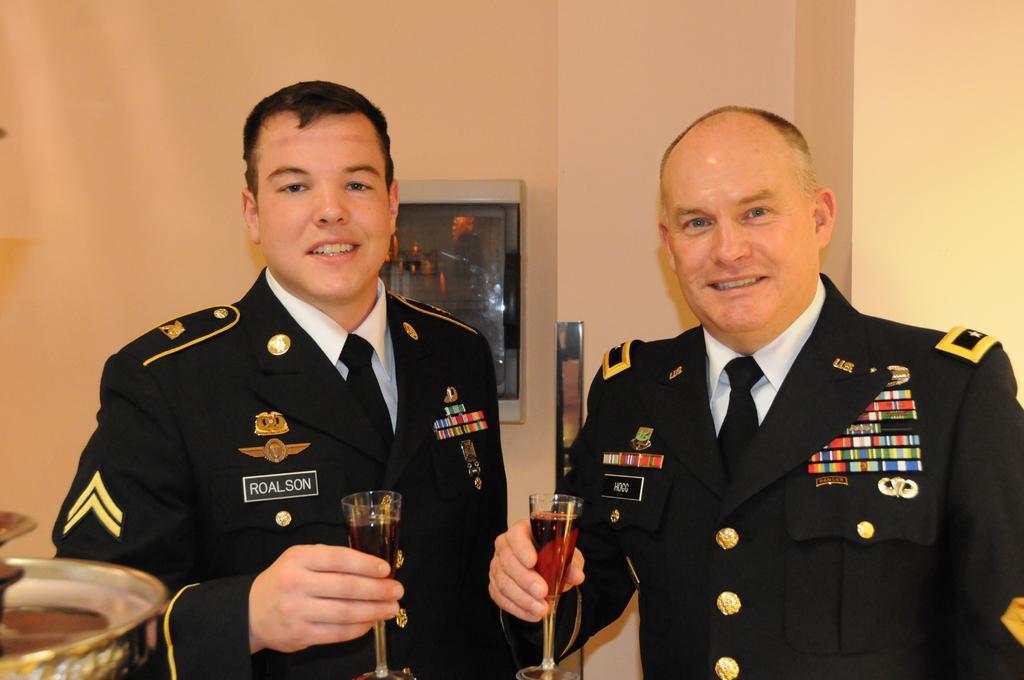Can you describe this image briefly? In this picture there are two men in the center of the image, by holding juice glasses in their hands and there is a box in the center of the image, on the wall. 